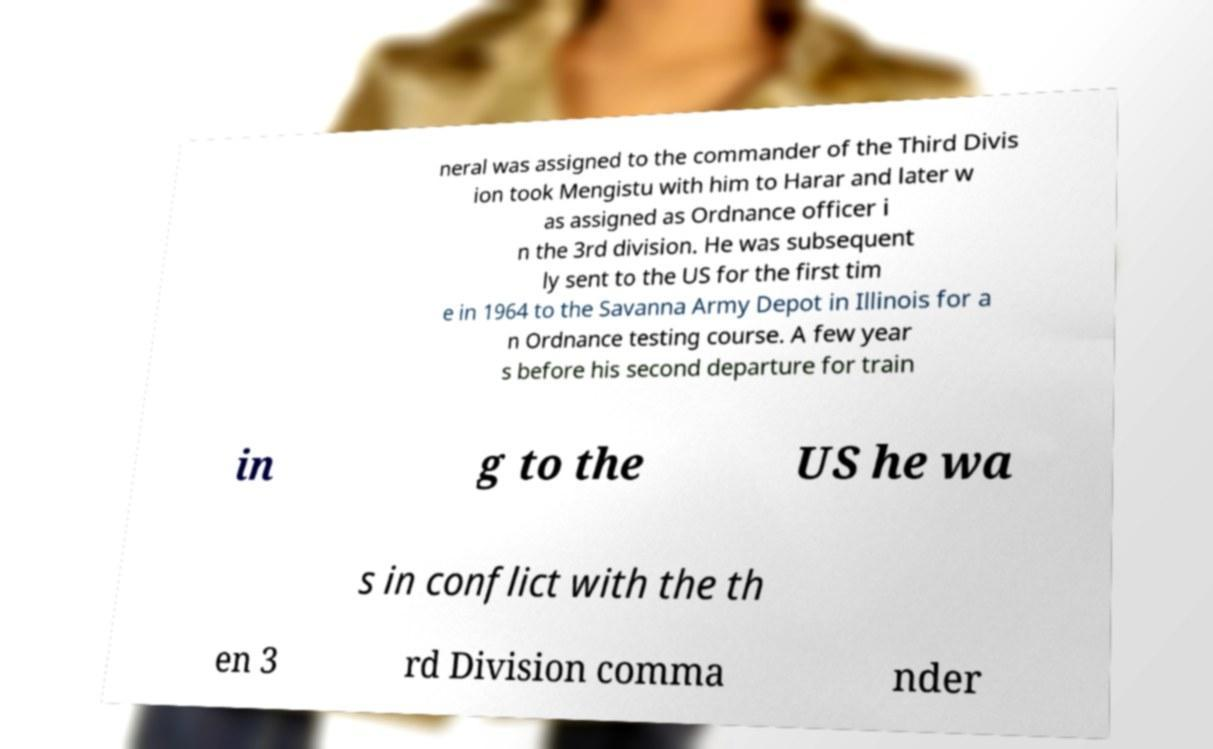Can you accurately transcribe the text from the provided image for me? neral was assigned to the commander of the Third Divis ion took Mengistu with him to Harar and later w as assigned as Ordnance officer i n the 3rd division. He was subsequent ly sent to the US for the first tim e in 1964 to the Savanna Army Depot in Illinois for a n Ordnance testing course. A few year s before his second departure for train in g to the US he wa s in conflict with the th en 3 rd Division comma nder 